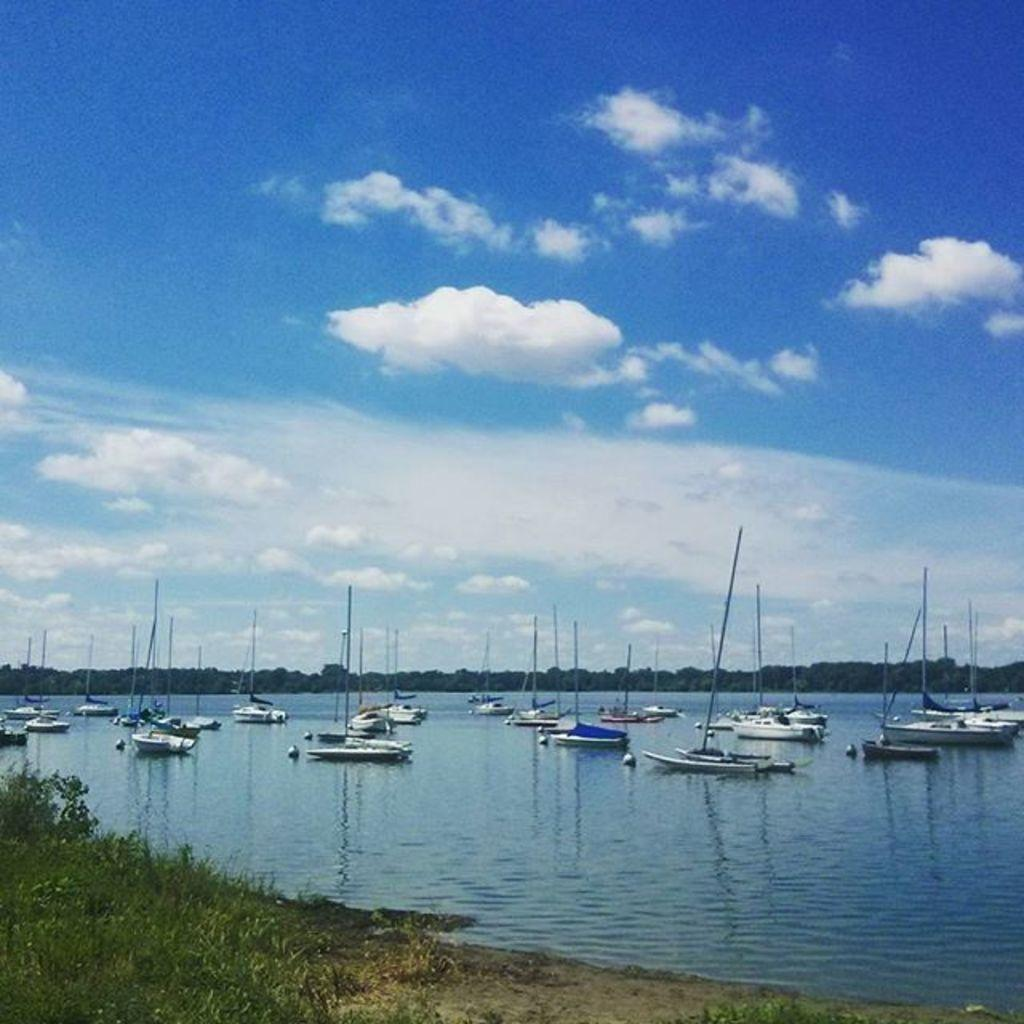What type of vehicles can be seen in the water in the image? There are boats in the water in the image. What type of vegetation is visible in the image? There are trees visible in the image. What type of land cover can be seen in the image? There is grass in the image. What is visible in the background of the image? The sky is visible in the background of the image. What type of soap is being used to clean the boats in the image? There is no soap present in the image, and no indication that the boats are being cleaned. 